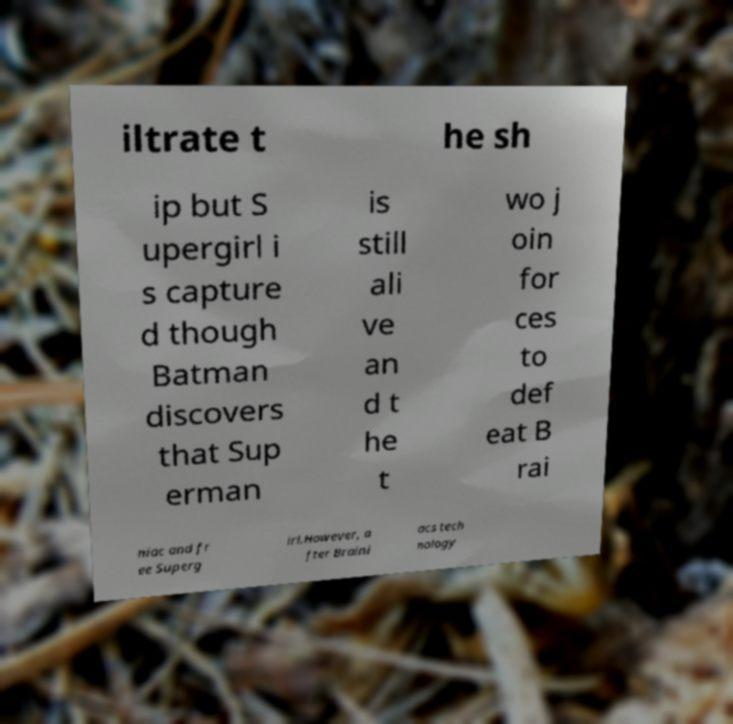Could you extract and type out the text from this image? iltrate t he sh ip but S upergirl i s capture d though Batman discovers that Sup erman is still ali ve an d t he t wo j oin for ces to def eat B rai niac and fr ee Superg irl.However, a fter Braini acs tech nology 